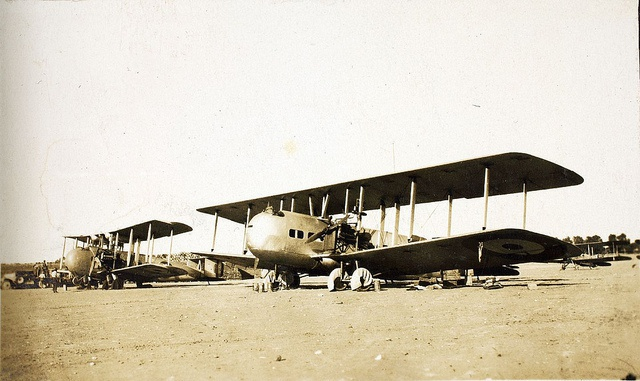Describe the objects in this image and their specific colors. I can see airplane in darkgray, black, ivory, tan, and olive tones and airplane in darkgray, black, ivory, tan, and olive tones in this image. 